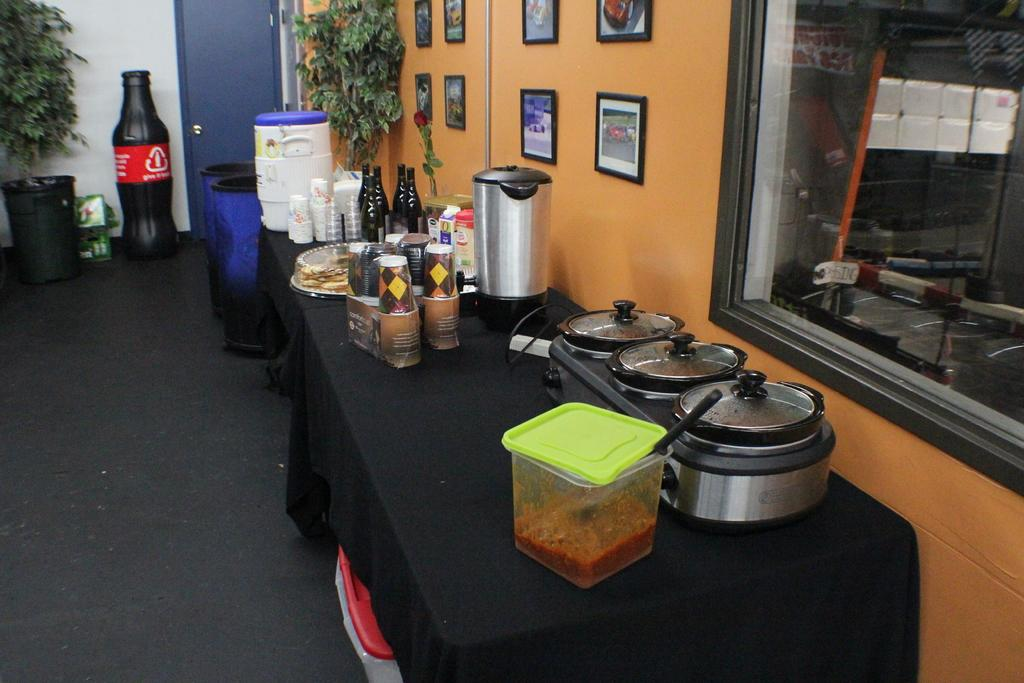Provide a one-sentence caption for the provided image. A soda-bottle shaped recycling container encourages people to "give it back.". 